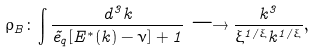Convert formula to latex. <formula><loc_0><loc_0><loc_500><loc_500>\rho _ { B } \colon \int \frac { d ^ { 3 } k } { \tilde { e } _ { q } [ E ^ { * } ( k ) - \nu ] + 1 } \longrightarrow \frac { k ^ { 3 } } { \xi ^ { 1 / \xi } k ^ { 1 / \xi } } , \\</formula> 